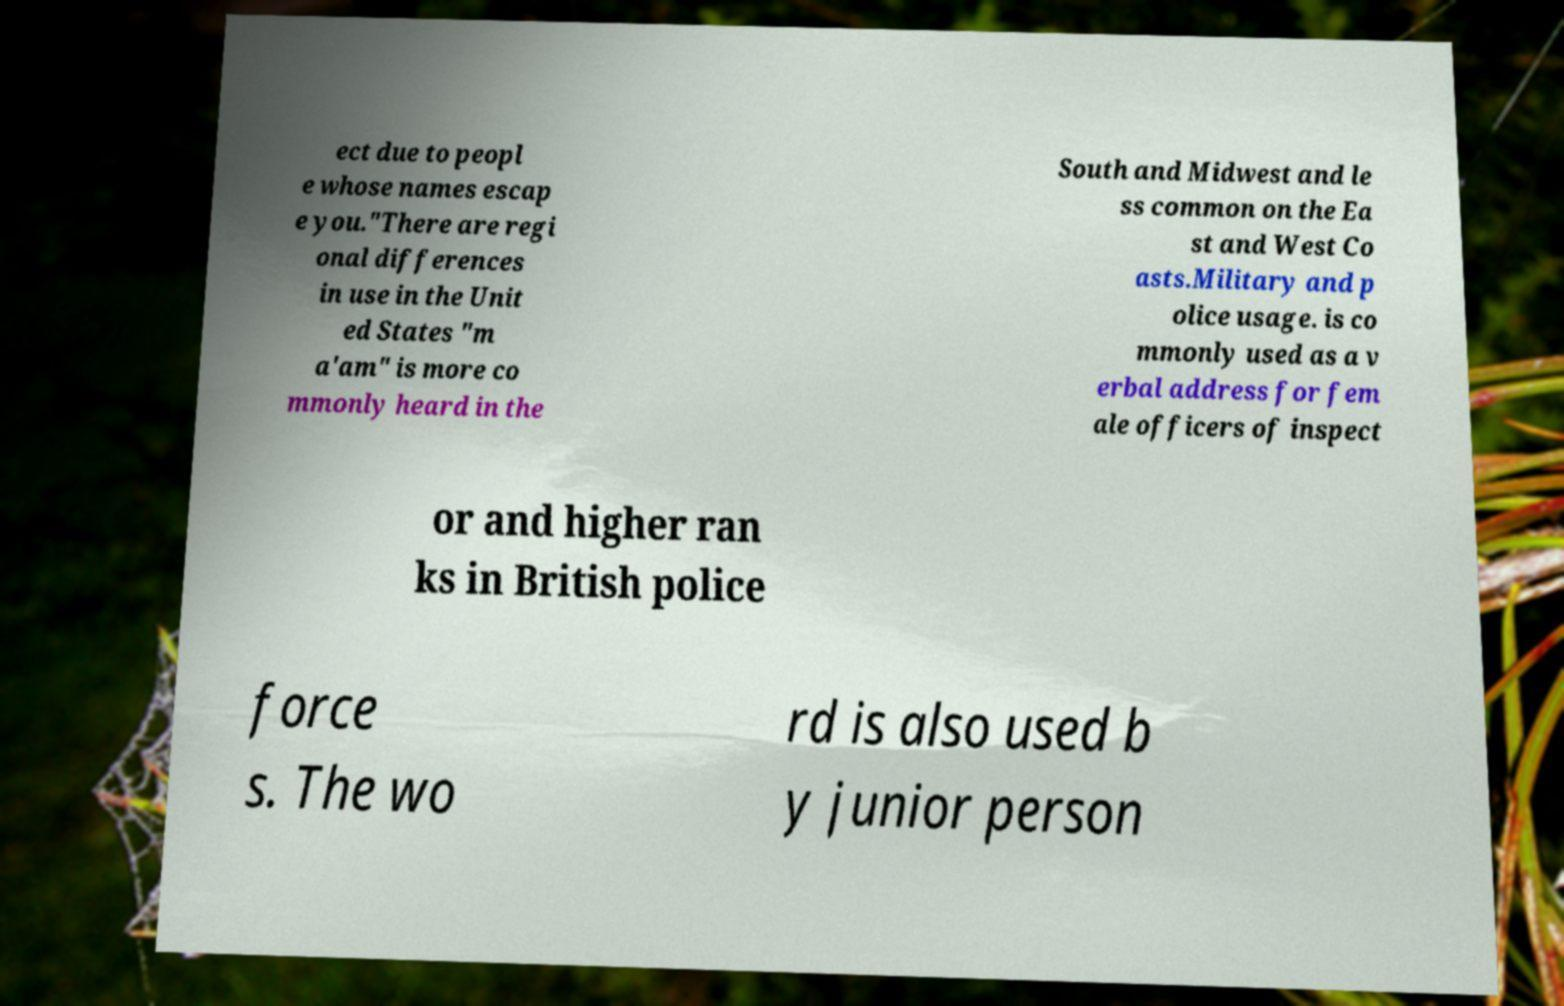Please identify and transcribe the text found in this image. ect due to peopl e whose names escap e you."There are regi onal differences in use in the Unit ed States "m a'am" is more co mmonly heard in the South and Midwest and le ss common on the Ea st and West Co asts.Military and p olice usage. is co mmonly used as a v erbal address for fem ale officers of inspect or and higher ran ks in British police force s. The wo rd is also used b y junior person 